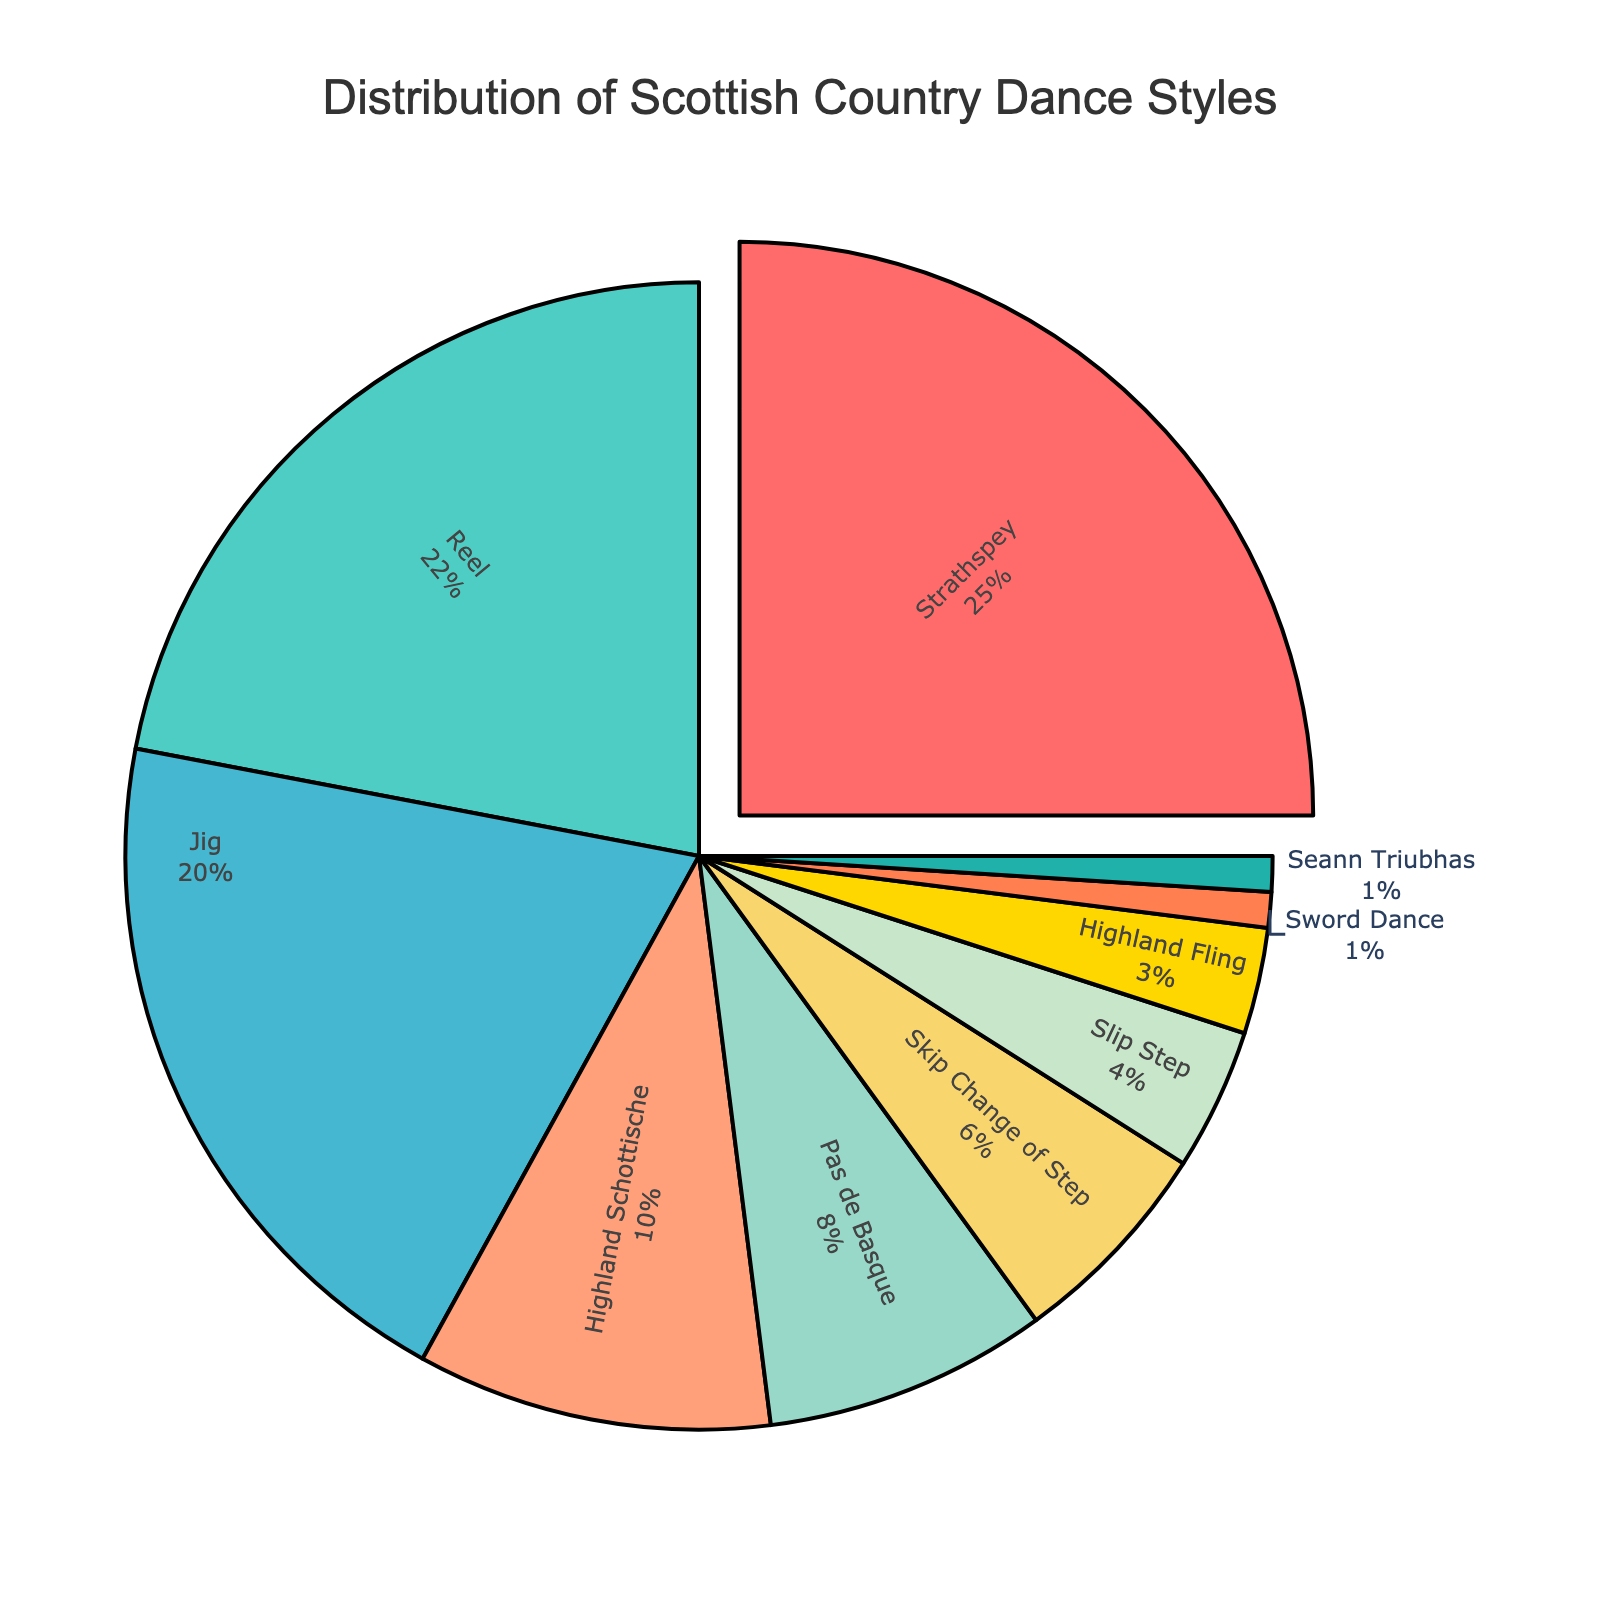What style of Scottish Country Dance has the highest percentage of practice among professional dancers? The largest section of the pie chart is slightly pulled out for emphasis, and it is labeled "Strathspey" with 25%.
Answer: Strathspey Which styles have a combined percentage equal to the percentage of 'Strathspey'? Strathspey has 25%. Adding the percentages of Jig (20%) and Seann Triubhas (1%) totals 25%, matching Strathspey.
Answer: Jig and Seann Triubhas How does the percentage of dancers practicing Reels compare to those practicing Highland Schottische? The pie chart shows Reel at 22% and Highland Schottische at 10%. Therefore, Reel is greater than Highland Schottische.
Answer: Reel is greater Which three styles collectively account for almost half of the total distribution? Summing the percentages of Strathspey (25%), Reel (22%), and Jig (20%) results in 67%, which is more than half of 100%. Only three styles are needed to exceed the half mark.
Answer: Strathspey, Reel, Jig What is the percentage difference between dancers practicing Slip Step and Highland Fling? Slip Step is at 4%, and Highland Fling is at 3%. The difference is calculated as 4% - 3% = 1%.
Answer: 1% List the styles practiced by less than 5% of dancers. The styles with percentages less than 5% are found at the least represented portions of the pie chart: Slip Step (4%), Highland Fling (3%), Sword Dance (1%), and Seann Triubhas (1%).
Answer: Slip Step, Highland Fling, Sword Dance, Seann Triubhas If you sum the percentages for Skip Change of Step and Pas de Basque, do they exceed the percentage for Jig? Skip Change of Step is 6%, and Pas de Basque is 8%. Their sum is 6% + 8% = 14%, which is less than Jig at 20%.
Answer: No Identify the style with the smallest percentage and describe its visual appearance in the pie chart. The smallest section in the pie chart, representing 1%, is labeled as Sword Dance and Seann Triubhas. They are the tiniest slices with minimal space.
Answer: Sword Dance and Seann Triubhas Which style segment uses the color green in the pie chart? The chart uses colors distinguishing each style, and Slip Step is marked with green. This is visually identifiable.
Answer: Slip Step 